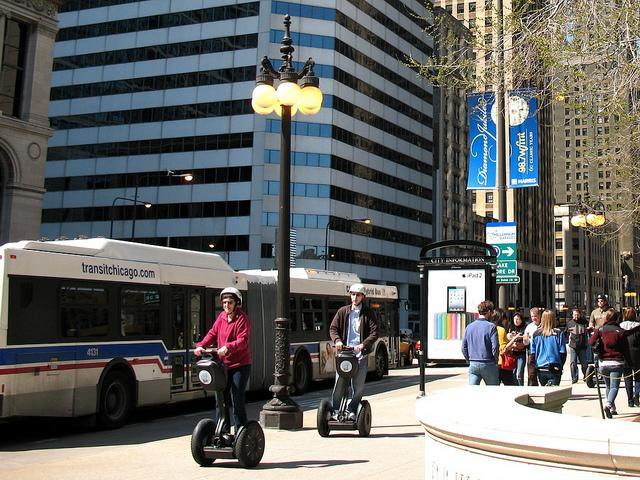Why are the the two riders wearing helmets? safety 